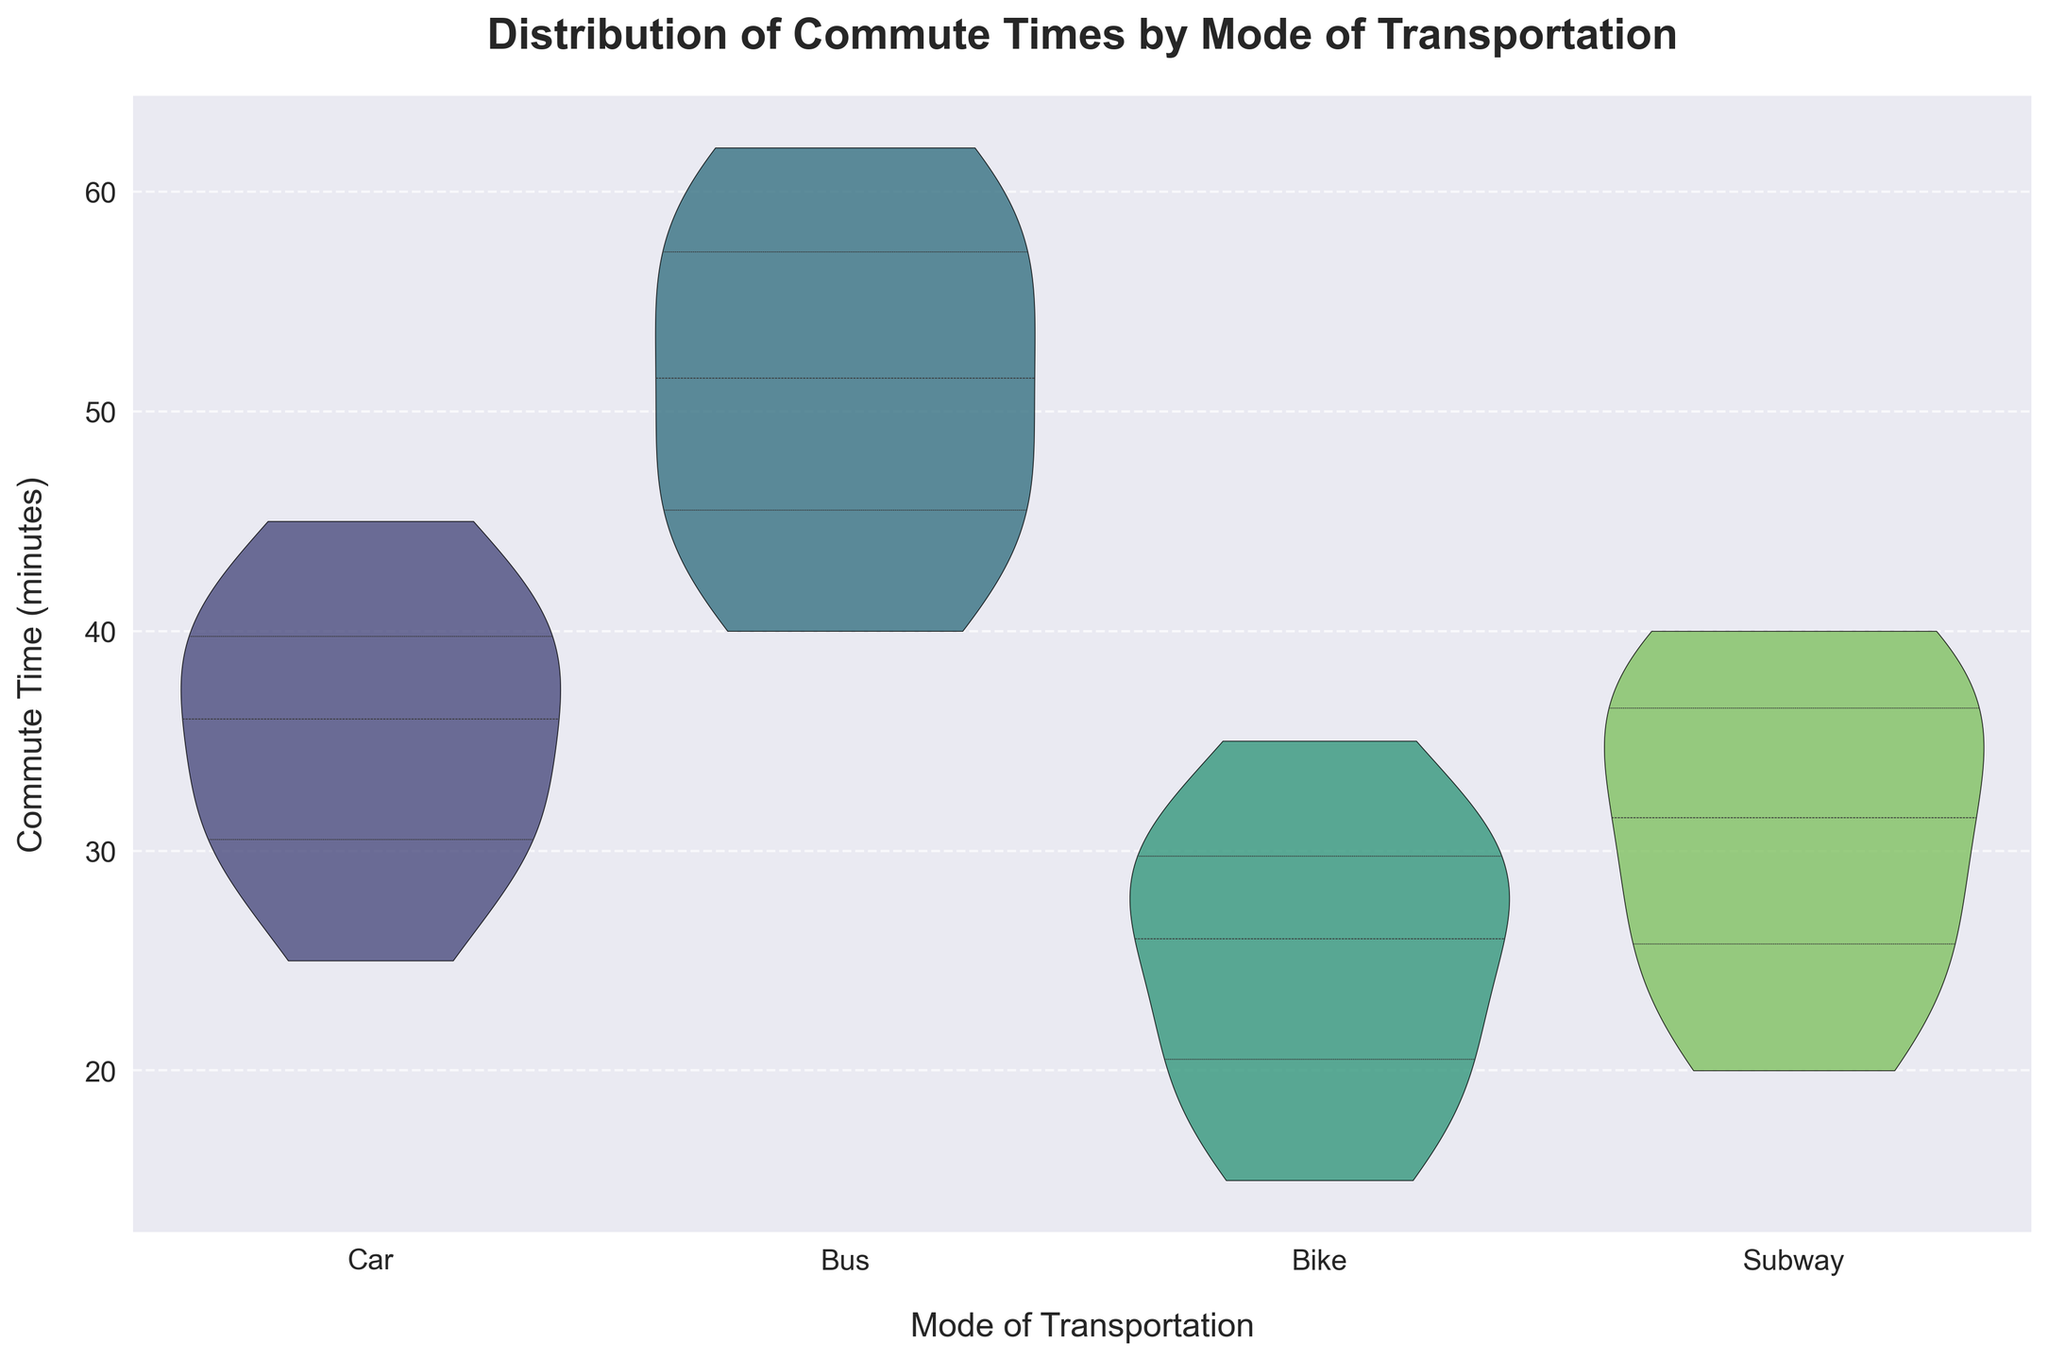What's the title of the figure? The title of the figure is written at the top of the plot. It reads "Distribution of Commute Times by Mode of Transportation."
Answer: Distribution of Commute Times by Mode of Transportation What are the modes of transportation considered in the figure? The x-axis of the violin plot represents different modes of transportation. The categories are "Car", "Bus", "Bike", and "Subway".
Answer: Car, Bus, Bike, Subway Which mode of transportation shows the smallest range of commute times? By observing the spread of the violin plots, the one with the smallest distribution span is for "Bike". The spread of the distribution shows it has the smallest range of commute times.
Answer: Bike What is the median commute time for car users? The median value is represented by the central white dot in the violin plot for "Car". This dot is located at around 35 minutes on the y-axis.
Answer: 35 minutes Which mode of transportation has the highest median commute time? The median value for each mode of transportation is indicated by the central white dot in each violin plot. "Bus" has the highest median value, around 50 minutes.
Answer: Bus How does the interquartile range for bike users compare to subway users? The interquartile range is represented by the thick black bar within each violin. For "Bike", this range is narrower and lies roughly between 20 to 30 minutes, while for "Subway", it spans around 25 to 35 minutes, indicating that "Subway" has a slightly wider interquartile range than "Bike".
Answer: Bike has a narrower interquartile range than Subway Are commute times more variable for car users or bus users? The variability in commute times is indicated by the width and spread of the violin plot. The violin plot for "Bus" is more spread out and wider compared to "Car", which means bus users have more variable commute times.
Answer: Bus users What is the maximum commute time recorded for subway users? The maximum value can be discerned by looking at the topmost extent of the violin plot for "Subway". This topmost point is around 40 minutes.
Answer: 40 minutes Which mode of transportation has the lowest minimum commute time? The minimum value can be found by looking at the bottom extent of each violin plot. The violin plot for "Bike" extends down to around 15 minutes, which is the lowest minimum commute time.
Answer: Bike 